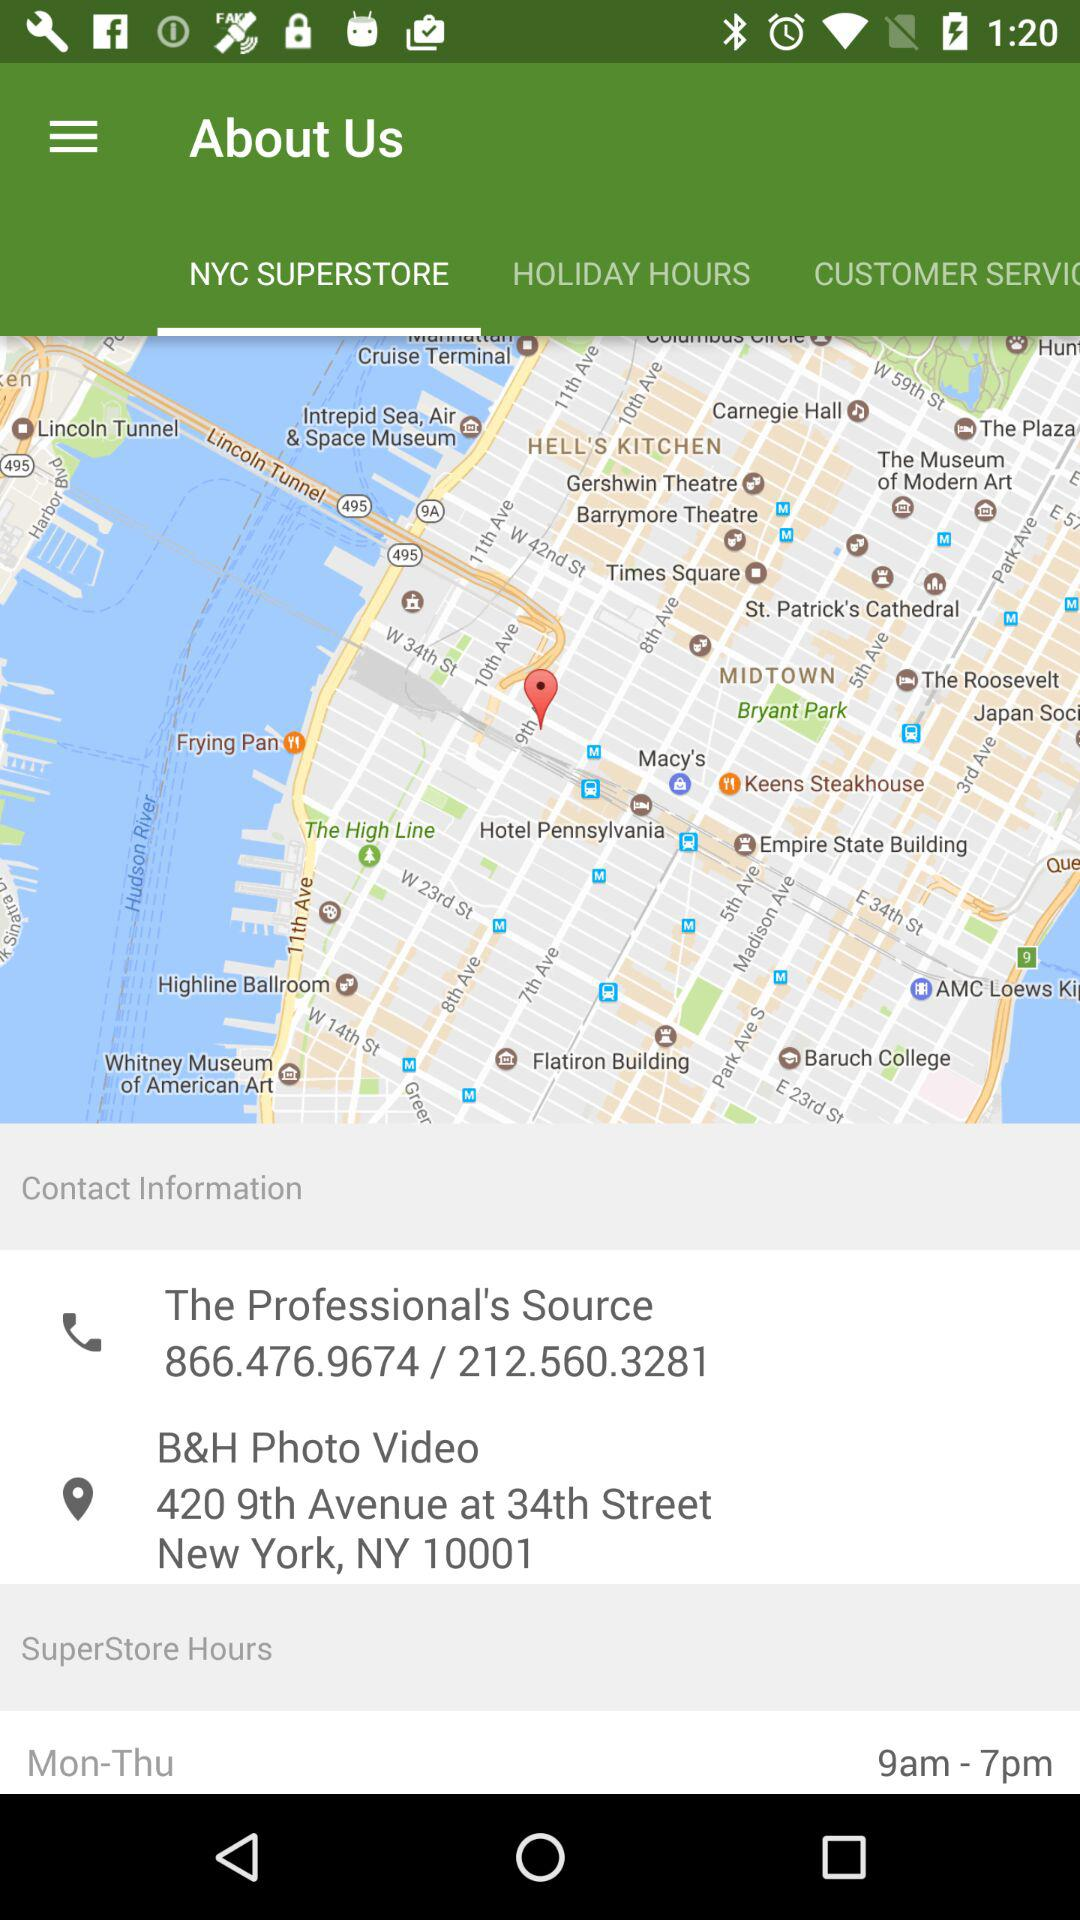What is the address of the superstore? The address is 420 9th Avenue at 34th Street, New York, NY 10001. 